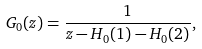<formula> <loc_0><loc_0><loc_500><loc_500>G _ { 0 } ( z ) = \frac { 1 } { z - H _ { 0 } ( 1 ) - H _ { 0 } ( 2 ) } ,</formula> 